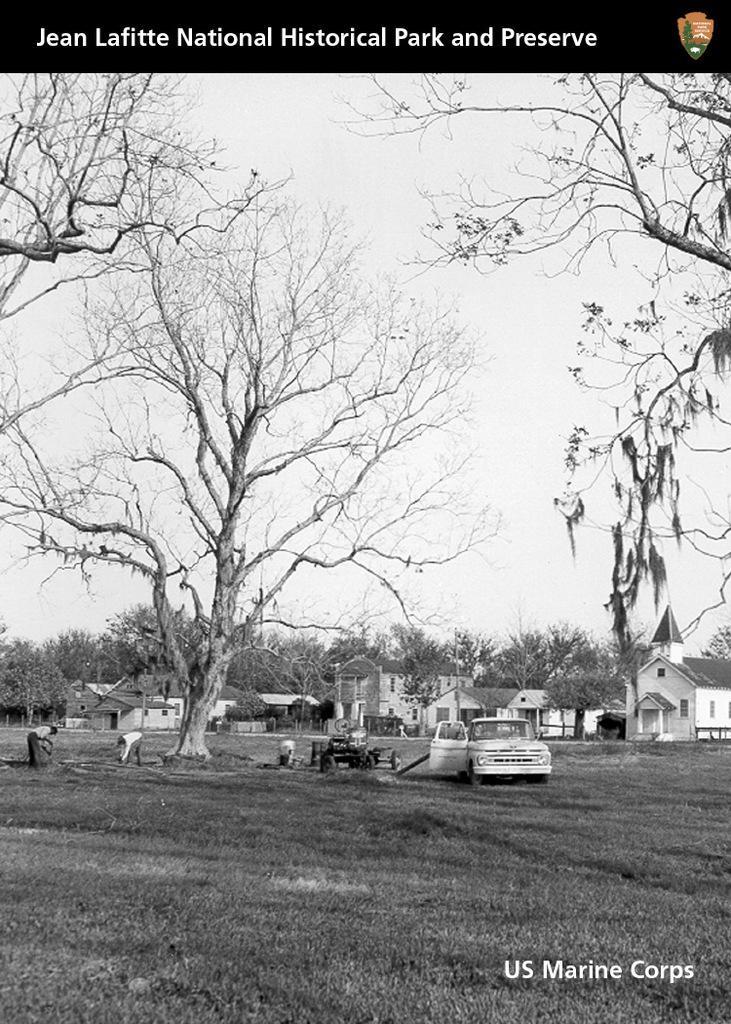In one or two sentences, can you explain what this image depicts? It is the black and white image in which there is a tree in the middle and there are houses beside it. On the ground there is a car and a tractor beside it. There are two people working on the ground. At the top there is sky. 